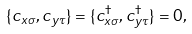Convert formula to latex. <formula><loc_0><loc_0><loc_500><loc_500>\{ { c } _ { x \sigma } , { c } _ { y \tau } \} = \{ { c } _ { x \sigma } ^ { \dagger } , { c } _ { y \tau } ^ { \dagger } \} = 0 ,</formula> 